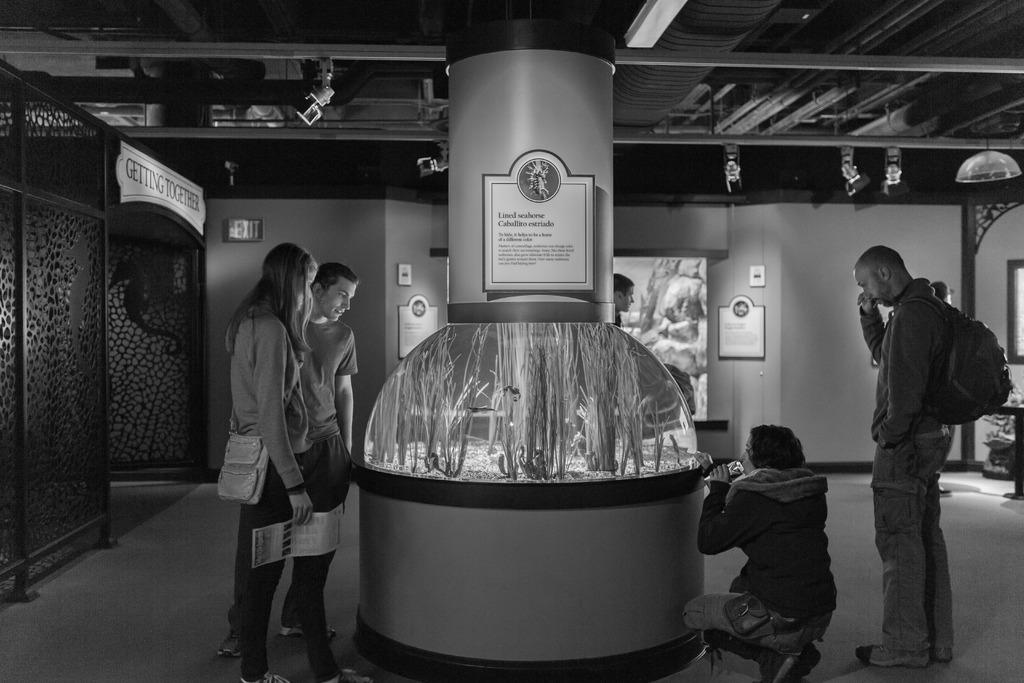What are the people in the image doing? The people in the image are on the floor. What can be seen in the background of the image? There is a wall visible in the image. What are the name boards used for in the image? The name boards are present in the image. Can you describe any objects in the image? There are objects in the image. What type of digestion issues are the people on the floor experiencing in the image? There is no indication of digestion issues in the image; the people are simply on the floor. 